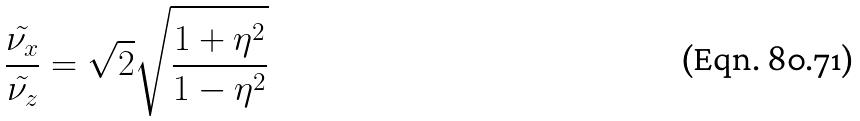<formula> <loc_0><loc_0><loc_500><loc_500>\frac { \tilde { \nu _ { x } } } { \tilde { \nu _ { z } } } = \sqrt { 2 } \sqrt { \frac { 1 + \eta ^ { 2 } } { 1 - \eta ^ { 2 } } }</formula> 